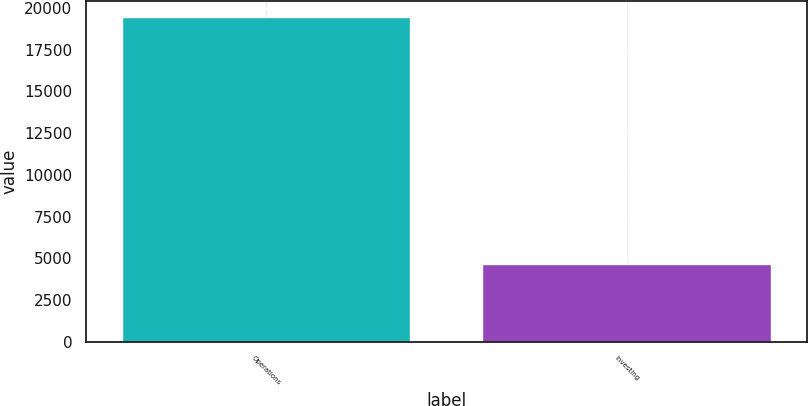<chart> <loc_0><loc_0><loc_500><loc_500><bar_chart><fcel>Operations<fcel>Investing<nl><fcel>19458<fcel>4679<nl></chart> 